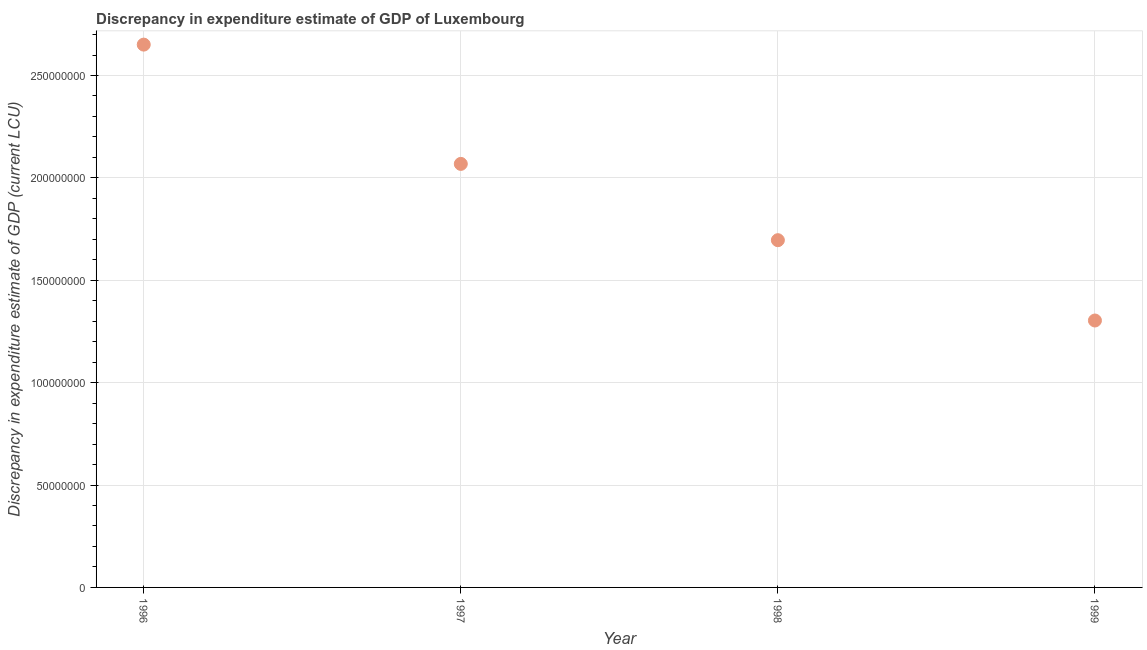What is the discrepancy in expenditure estimate of gdp in 1996?
Ensure brevity in your answer.  2.65e+08. Across all years, what is the maximum discrepancy in expenditure estimate of gdp?
Offer a very short reply. 2.65e+08. Across all years, what is the minimum discrepancy in expenditure estimate of gdp?
Provide a short and direct response. 1.30e+08. What is the sum of the discrepancy in expenditure estimate of gdp?
Ensure brevity in your answer.  7.72e+08. What is the difference between the discrepancy in expenditure estimate of gdp in 1998 and 1999?
Offer a very short reply. 3.92e+07. What is the average discrepancy in expenditure estimate of gdp per year?
Ensure brevity in your answer.  1.93e+08. What is the median discrepancy in expenditure estimate of gdp?
Provide a succinct answer. 1.88e+08. What is the ratio of the discrepancy in expenditure estimate of gdp in 1996 to that in 1997?
Make the answer very short. 1.28. Is the discrepancy in expenditure estimate of gdp in 1996 less than that in 1998?
Ensure brevity in your answer.  No. What is the difference between the highest and the second highest discrepancy in expenditure estimate of gdp?
Make the answer very short. 5.83e+07. What is the difference between the highest and the lowest discrepancy in expenditure estimate of gdp?
Your answer should be compact. 1.35e+08. In how many years, is the discrepancy in expenditure estimate of gdp greater than the average discrepancy in expenditure estimate of gdp taken over all years?
Ensure brevity in your answer.  2. Does the discrepancy in expenditure estimate of gdp monotonically increase over the years?
Give a very brief answer. No. How many years are there in the graph?
Provide a short and direct response. 4. Are the values on the major ticks of Y-axis written in scientific E-notation?
Provide a short and direct response. No. What is the title of the graph?
Offer a terse response. Discrepancy in expenditure estimate of GDP of Luxembourg. What is the label or title of the Y-axis?
Provide a succinct answer. Discrepancy in expenditure estimate of GDP (current LCU). What is the Discrepancy in expenditure estimate of GDP (current LCU) in 1996?
Ensure brevity in your answer.  2.65e+08. What is the Discrepancy in expenditure estimate of GDP (current LCU) in 1997?
Your answer should be very brief. 2.07e+08. What is the Discrepancy in expenditure estimate of GDP (current LCU) in 1998?
Give a very brief answer. 1.70e+08. What is the Discrepancy in expenditure estimate of GDP (current LCU) in 1999?
Provide a short and direct response. 1.30e+08. What is the difference between the Discrepancy in expenditure estimate of GDP (current LCU) in 1996 and 1997?
Provide a short and direct response. 5.83e+07. What is the difference between the Discrepancy in expenditure estimate of GDP (current LCU) in 1996 and 1998?
Make the answer very short. 9.55e+07. What is the difference between the Discrepancy in expenditure estimate of GDP (current LCU) in 1996 and 1999?
Your response must be concise. 1.35e+08. What is the difference between the Discrepancy in expenditure estimate of GDP (current LCU) in 1997 and 1998?
Your response must be concise. 3.73e+07. What is the difference between the Discrepancy in expenditure estimate of GDP (current LCU) in 1997 and 1999?
Your response must be concise. 7.65e+07. What is the difference between the Discrepancy in expenditure estimate of GDP (current LCU) in 1998 and 1999?
Provide a short and direct response. 3.92e+07. What is the ratio of the Discrepancy in expenditure estimate of GDP (current LCU) in 1996 to that in 1997?
Your answer should be very brief. 1.28. What is the ratio of the Discrepancy in expenditure estimate of GDP (current LCU) in 1996 to that in 1998?
Ensure brevity in your answer.  1.56. What is the ratio of the Discrepancy in expenditure estimate of GDP (current LCU) in 1996 to that in 1999?
Keep it short and to the point. 2.03. What is the ratio of the Discrepancy in expenditure estimate of GDP (current LCU) in 1997 to that in 1998?
Your answer should be very brief. 1.22. What is the ratio of the Discrepancy in expenditure estimate of GDP (current LCU) in 1997 to that in 1999?
Your response must be concise. 1.59. What is the ratio of the Discrepancy in expenditure estimate of GDP (current LCU) in 1998 to that in 1999?
Make the answer very short. 1.3. 